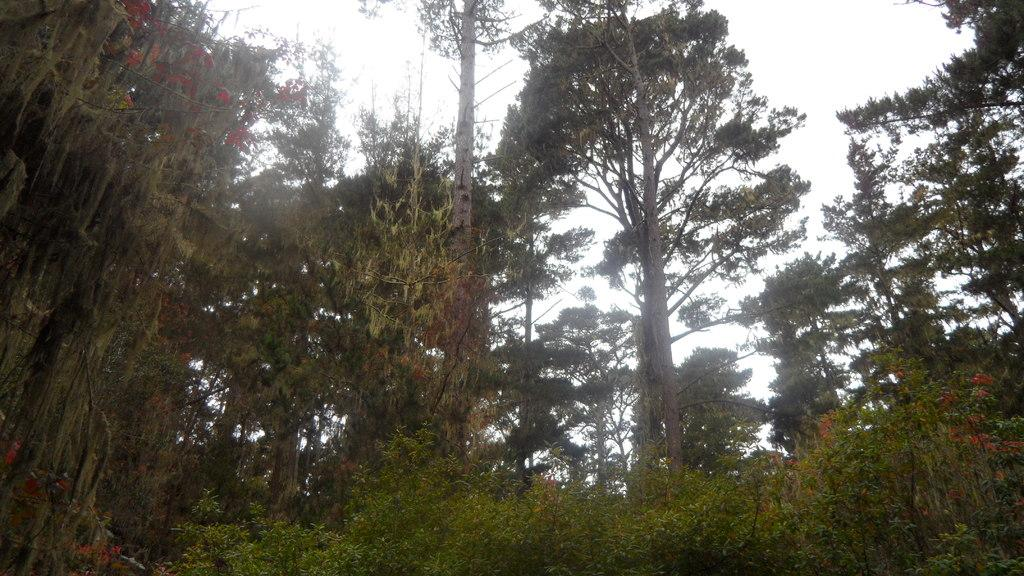What type of vegetation can be seen in the image? There are trees in the image. What other natural elements can be seen in the image? There are flowers in the image. What is visible at the top of the image? The sky is visible at the top of the image. What is the chance of finding a footprint in the image? There is no reference to a footprint or any indication of a footprint being present in the image. 